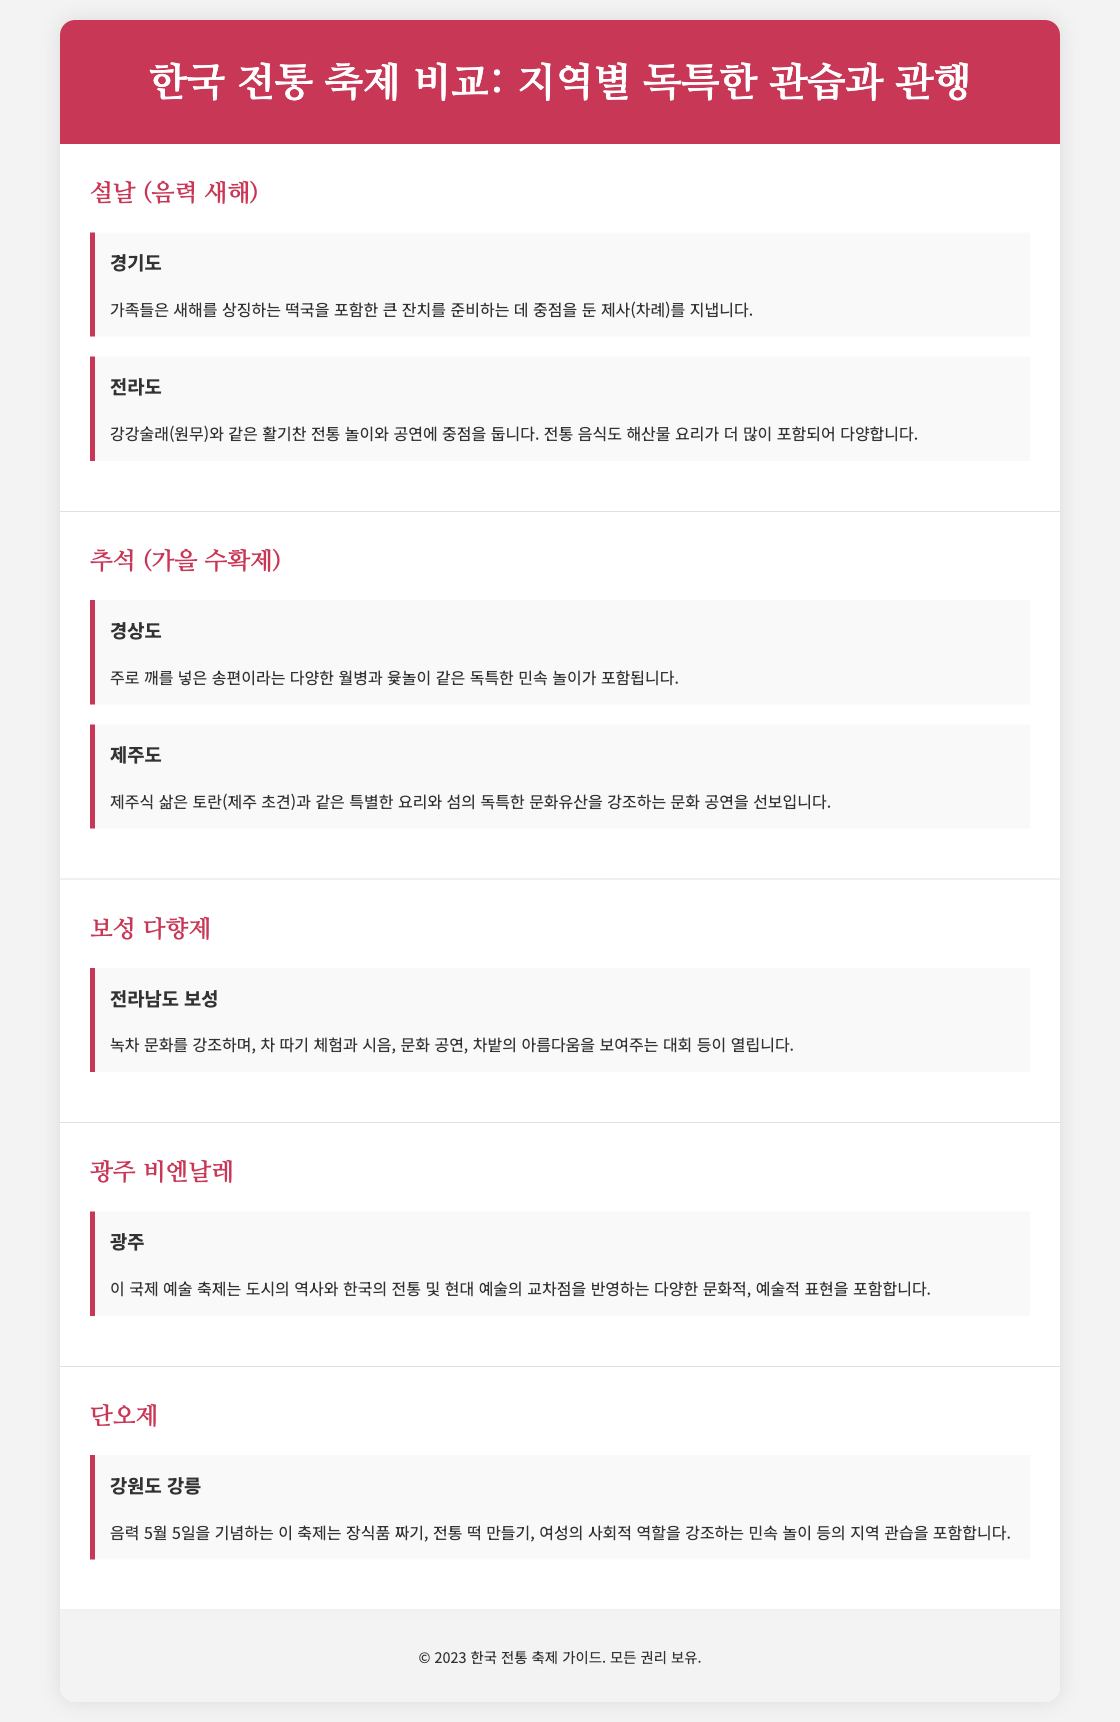What is the first festival mentioned? The first festival listed in the document is 설날 (음력 새해).
Answer: 설날 (음력 새해) Which region focuses on traditional games during 설날? The region that emphasizes traditional games during 설날 is 전라도, known for 강강술래.
Answer: 전라도 What type of food is highlighted in 경상도의 추석? The special food highlighted in 경상도의 추석 is 송편, which has 깨.
Answer: 송편 Which festival is celebrated in 전라남도 보성? The festival celebrated in 전라남도 보성 is 보성 다향제.
Answer: 보성 다향제 What is a unique custom related to 단오제 in 강원도 강릉? A unique custom related to 단오제 in 강원도 강릉 is 전통 떡 만들기.
Answer: 전통 떡 만들기 Which festival reflects the intersection of traditional and modern art? The festival that reflects the intersection of traditional and modern art is 광주 비엔날레.
Answer: 광주 비엔날레 How many regions are discussed in the context of 설날? The document discusses two regions in the context of 설날.
Answer: 두 개 What type of event does the 보성 다향제 include? The 보성 다향제 includes 차 따기 체험.
Answer: 차 따기 체험 What is the main theme of 추석 in 제주도? The main theme of 추석 in 제주도 is highlighted through 특별한 요리.
Answer: 특별한 요리 